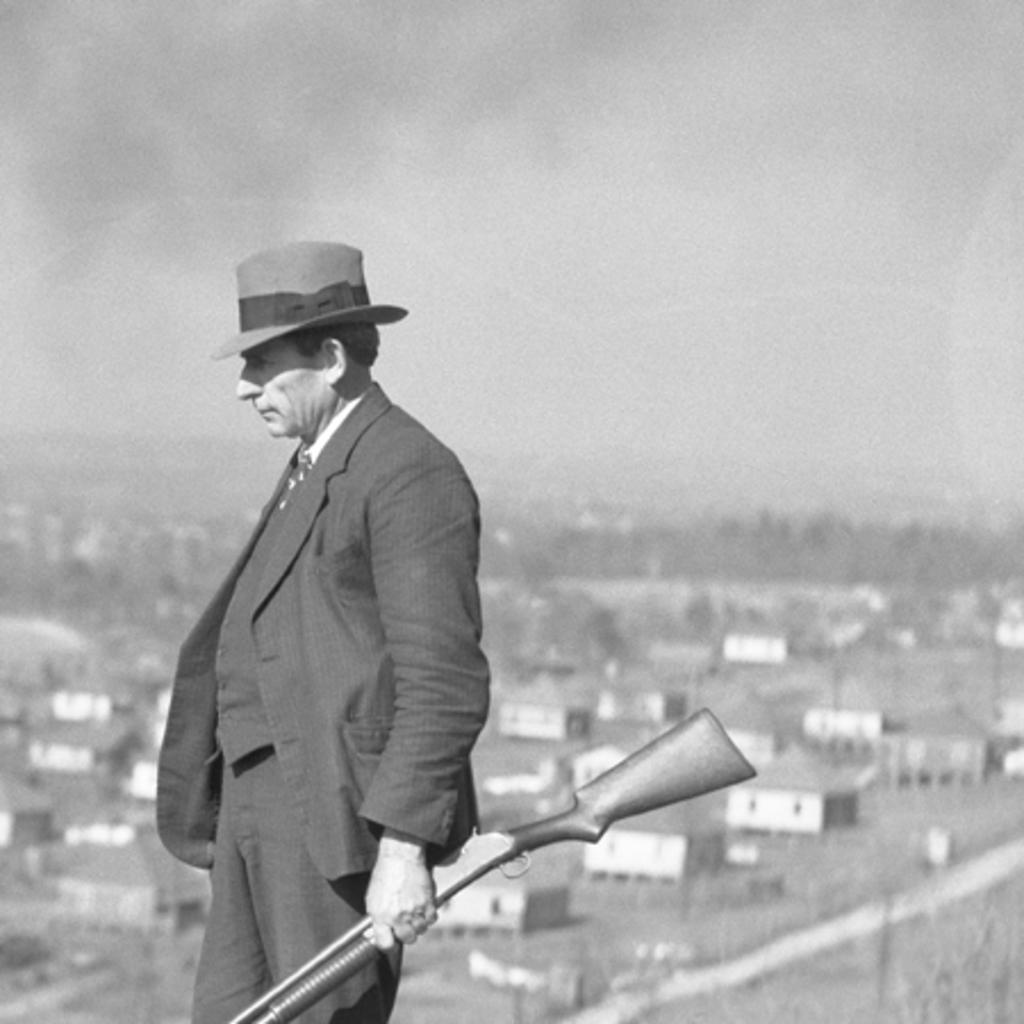How would you summarize this image in a sentence or two? In this picture I can see a man holding a gun in his hand and I can see few houses and man is wearing a cap on his head and I can see sky. 